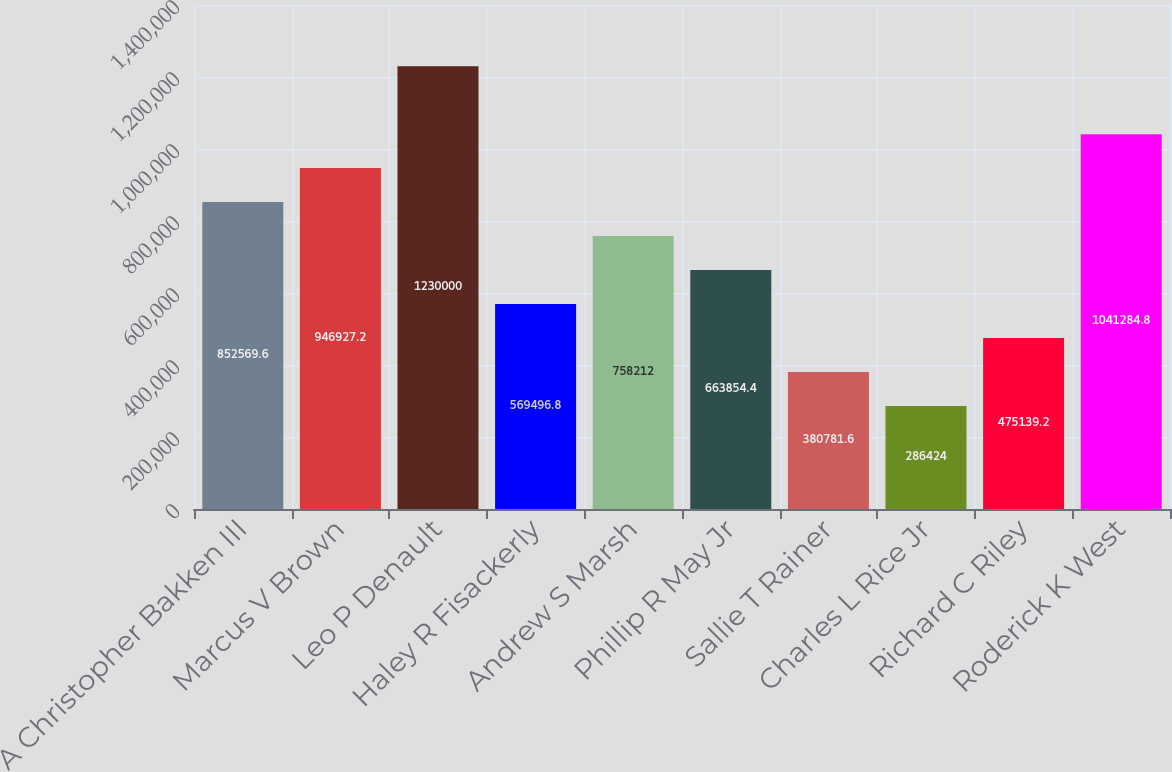<chart> <loc_0><loc_0><loc_500><loc_500><bar_chart><fcel>A Christopher Bakken III<fcel>Marcus V Brown<fcel>Leo P Denault<fcel>Haley R Fisackerly<fcel>Andrew S Marsh<fcel>Phillip R May Jr<fcel>Sallie T Rainer<fcel>Charles L Rice Jr<fcel>Richard C Riley<fcel>Roderick K West<nl><fcel>852570<fcel>946927<fcel>1.23e+06<fcel>569497<fcel>758212<fcel>663854<fcel>380782<fcel>286424<fcel>475139<fcel>1.04128e+06<nl></chart> 